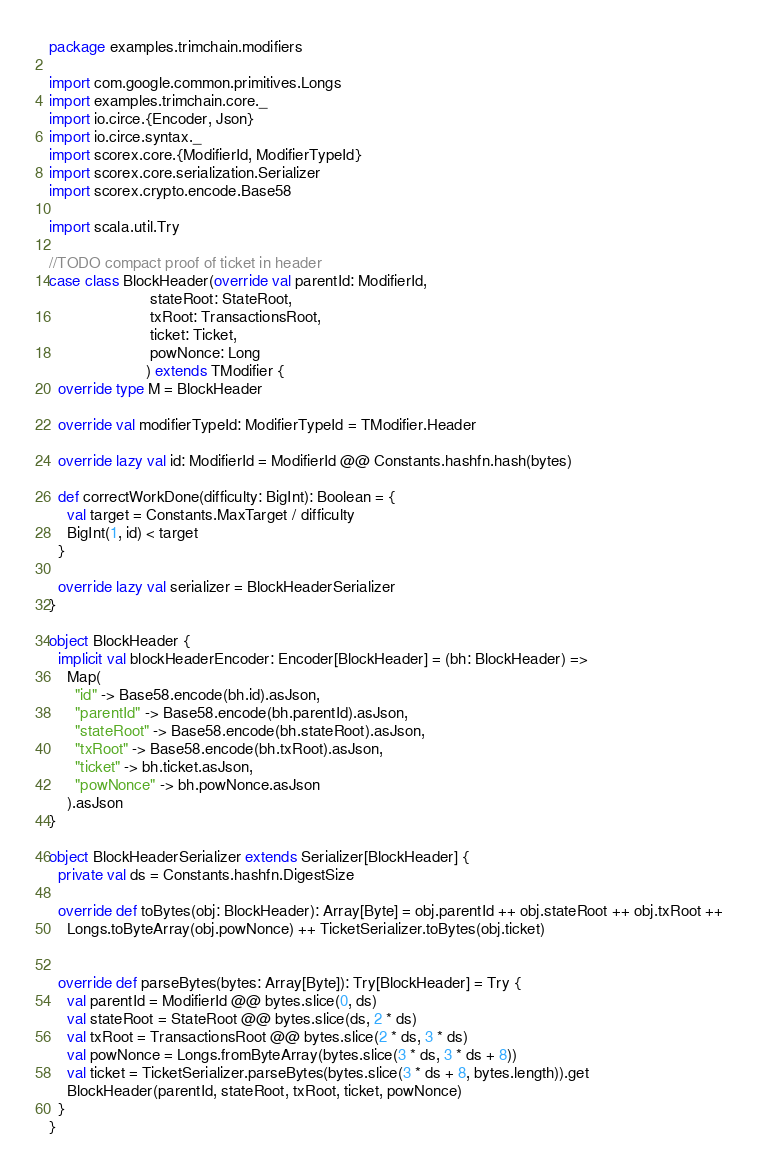Convert code to text. <code><loc_0><loc_0><loc_500><loc_500><_Scala_>package examples.trimchain.modifiers

import com.google.common.primitives.Longs
import examples.trimchain.core._
import io.circe.{Encoder, Json}
import io.circe.syntax._
import scorex.core.{ModifierId, ModifierTypeId}
import scorex.core.serialization.Serializer
import scorex.crypto.encode.Base58

import scala.util.Try

//TODO compact proof of ticket in header
case class BlockHeader(override val parentId: ModifierId,
                       stateRoot: StateRoot,
                       txRoot: TransactionsRoot,
                       ticket: Ticket,
                       powNonce: Long
                      ) extends TModifier {
  override type M = BlockHeader

  override val modifierTypeId: ModifierTypeId = TModifier.Header

  override lazy val id: ModifierId = ModifierId @@ Constants.hashfn.hash(bytes)

  def correctWorkDone(difficulty: BigInt): Boolean = {
    val target = Constants.MaxTarget / difficulty
    BigInt(1, id) < target
  }

  override lazy val serializer = BlockHeaderSerializer
}

object BlockHeader {
  implicit val blockHeaderEncoder: Encoder[BlockHeader] = (bh: BlockHeader) =>
    Map(
      "id" -> Base58.encode(bh.id).asJson,
      "parentId" -> Base58.encode(bh.parentId).asJson,
      "stateRoot" -> Base58.encode(bh.stateRoot).asJson,
      "txRoot" -> Base58.encode(bh.txRoot).asJson,
      "ticket" -> bh.ticket.asJson,
      "powNonce" -> bh.powNonce.asJson
    ).asJson
}

object BlockHeaderSerializer extends Serializer[BlockHeader] {
  private val ds = Constants.hashfn.DigestSize

  override def toBytes(obj: BlockHeader): Array[Byte] = obj.parentId ++ obj.stateRoot ++ obj.txRoot ++
    Longs.toByteArray(obj.powNonce) ++ TicketSerializer.toBytes(obj.ticket)


  override def parseBytes(bytes: Array[Byte]): Try[BlockHeader] = Try {
    val parentId = ModifierId @@ bytes.slice(0, ds)
    val stateRoot = StateRoot @@ bytes.slice(ds, 2 * ds)
    val txRoot = TransactionsRoot @@ bytes.slice(2 * ds, 3 * ds)
    val powNonce = Longs.fromByteArray(bytes.slice(3 * ds, 3 * ds + 8))
    val ticket = TicketSerializer.parseBytes(bytes.slice(3 * ds + 8, bytes.length)).get
    BlockHeader(parentId, stateRoot, txRoot, ticket, powNonce)
  }
}
</code> 